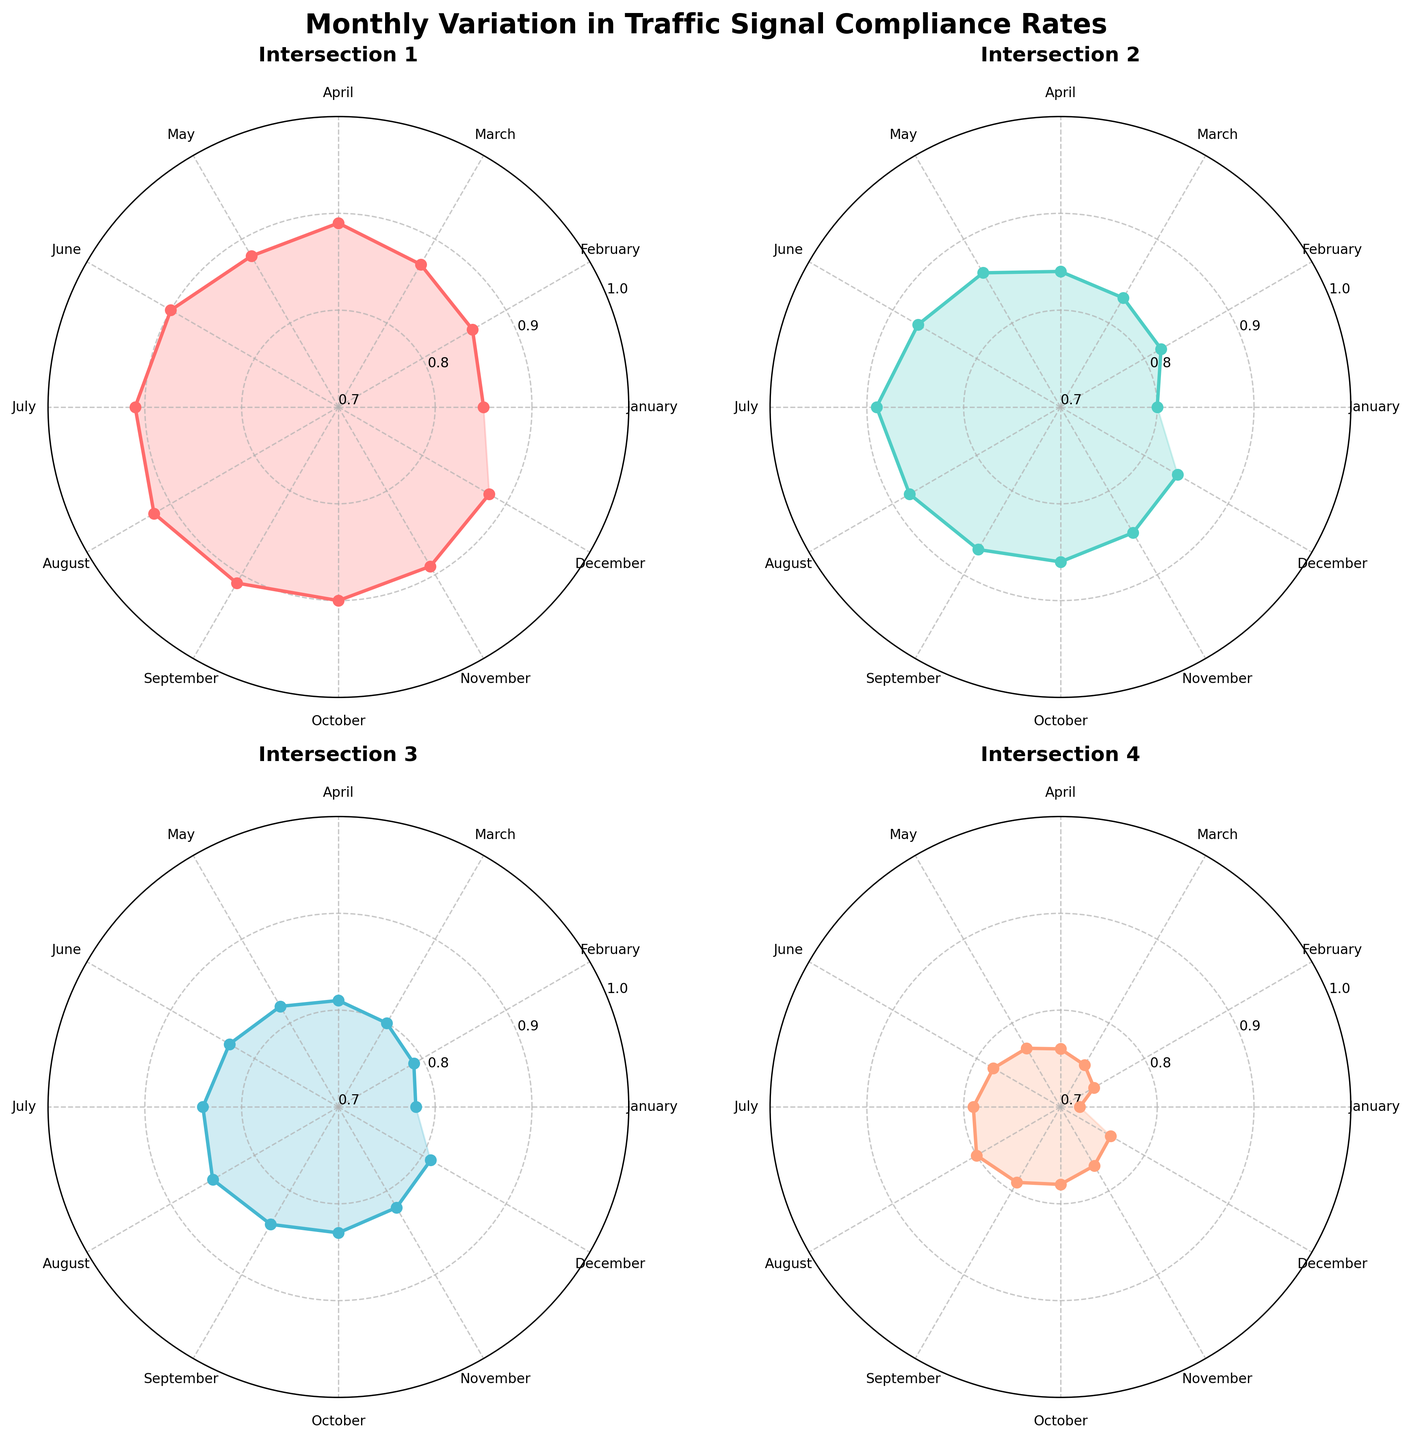What is the title of the figure? The title is usually found at the top of the figure, concisely describing the content of the plot. It is "Monthly Variation in Traffic Signal Compliance Rates."
Answer: Monthly Variation in Traffic Signal Compliance Rates Which intersection has the lowest compliance rate in January? In January, Intersection 4 has the lowest compliance rate. This can be visually determined by looking at the starting points on the radial plot which shows the January values for all intersections. Intersection 4 starts at a lower value compared to the others.
Answer: Intersection 4 Which month shows the highest compliance rate for Intersection 1? The highest compliance rate for Intersection 1 is observed in August, depicted by the peak value on its respective subplot.
Answer: August Compare the compliance rates of Intersections 2 and 3 in June. Which one is higher? By comparing the values at the June mark on both subplots for Intersections 2 and 3, it is clear that Intersection 2 has a higher value.
Answer: Intersection 2 Calculate the average compliance rate for Intersection 4 over the year. Sum the monthly compliance rates for Intersection 4 and divide by the number of months (12): (0.72 + 0.74 + 0.75 + 0.76 + 0.77 + 0.78 + 0.79 + 0.80 + 0.79 + 0.78 + 0.77 + 0.76) / 12 ≈ 0.764
Answer: 0.764 Which intersection has the most gradual increase in compliance rates from January to December? To find the intersection with the most gradual increase, observe the slopes of the lines plotted for each intersection. Intersection 3 shows a relatively smooth and gradual increase compared to others with visible spikes or dips.
Answer: Intersection 3 What is the compliance rate difference between July and November for Intersection 1? Look at the respective compliance rates for Intersection 1 in July (0.91) and November (0.89), then calculate the difference: 0.91 - 0.89 = 0.02
Answer: 0.02 How many intersections have a compliance rate above 0.90 in August? Observe the values for August on each subplot. Intersection 1 (0.92) and Intersection 3 (0.85) have values above 0.90. So, just one intersection meets this criterion.
Answer: One During which month is the compliance rate the same for Intersections 3 and 4? Carefully observe the monthly rates on both subplots; both Intersections 3 and 4 have the same compliance rate (0.79) in July and September.
Answer: July and September 